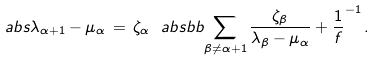Convert formula to latex. <formula><loc_0><loc_0><loc_500><loc_500>\ a b s { \lambda _ { \alpha + 1 } - \mu _ { \alpha } } \, = \, \zeta _ { \alpha } \ a b s b b { \sum _ { \beta \neq \alpha + 1 } \frac { \zeta _ { \beta } } { \lambda _ { \beta } - \mu _ { \alpha } } + \frac { 1 } { f } } ^ { - 1 } \, .</formula> 